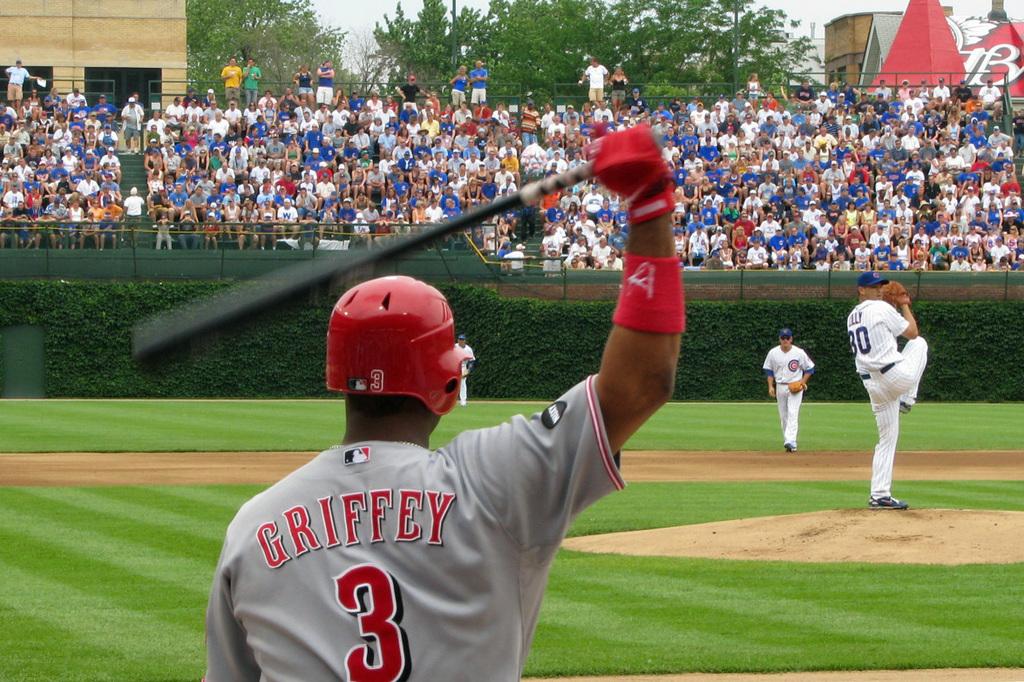Who is the player?
Offer a terse response. Griffey. What is the players number?
Offer a very short reply. 3. 